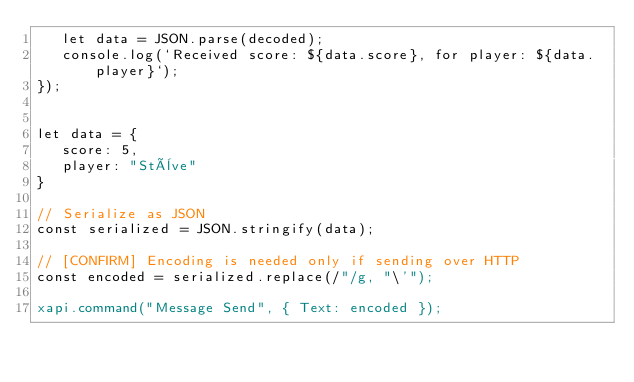Convert code to text. <code><loc_0><loc_0><loc_500><loc_500><_JavaScript_>   let data = JSON.parse(decoded);
   console.log(`Received score: ${data.score}, for player: ${data.player}`);
});


let data = {
   score: 5,
   player: "Stève"
}

// Serialize as JSON
const serialized = JSON.stringify(data);

// [CONFIRM] Encoding is needed only if sending over HTTP
const encoded = serialized.replace(/"/g, "\'");

xapi.command("Message Send", { Text: encoded });</code> 